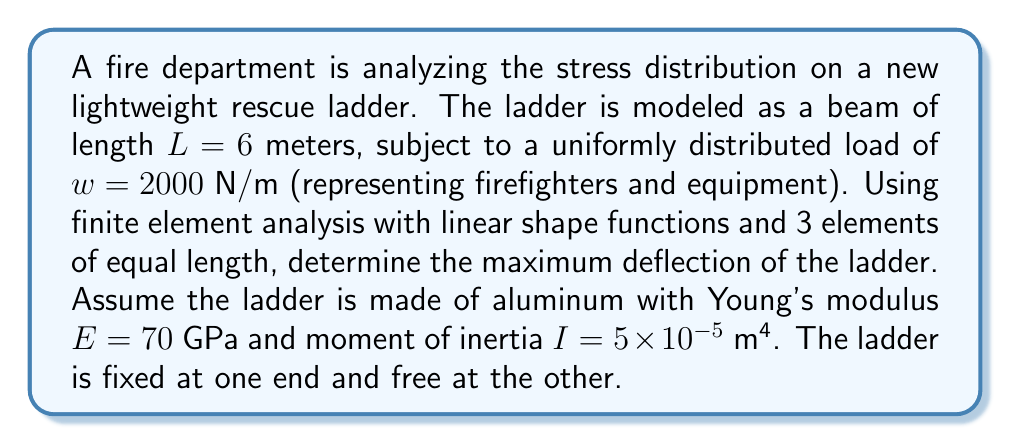Show me your answer to this math problem. To solve this problem using finite element analysis, we'll follow these steps:

1) First, we need to set up the stiffness matrix for a single element. For a beam element with linear shape functions, the element stiffness matrix is:

   $$K_e = \frac{EI}{l^3} \begin{bmatrix} 
   12 & 6l & -12 & 6l \\
   6l & 4l^2 & -6l & 2l^2 \\
   -12 & -6l & 12 & -6l \\
   6l & 2l^2 & -6l & 4l^2
   \end{bmatrix}$$

   where $l$ is the length of each element.

2) We have 3 elements, each of length $l = L/3 = 2$ m.

3) Assemble the global stiffness matrix $K$ by combining the element stiffness matrices.

4) The force vector $F$ for a uniformly distributed load $w$ on a beam element is:

   $$F_e = \frac{wl}{2} \begin{bmatrix} 1 \\ l/6 \\ 1 \\ -l/6 \end{bmatrix}$$

5) Assemble the global force vector.

6) Apply boundary conditions: fix the first node (degrees of freedom 1 and 2).

7) Solve the system $Ku = F$ for the nodal displacements $u$.

8) The maximum deflection will occur at the free end (last node).

Carrying out these steps:

1) $K_e = \frac{70 \times 10^9 \times 5 \times 10^{-5}}{2^3} \begin{bmatrix} 
   12 & 12 & -12 & 12 \\
   12 & 16 & -12 & 8 \\
   -12 & -12 & 12 & -12 \\
   12 & 8 & -12 & 16
   \end{bmatrix} = 21875000 \begin{bmatrix} 
   12 & 12 & -12 & 12 \\
   12 & 16 & -12 & 8 \\
   -12 & -12 & 12 & -12 \\
   12 & 8 & -12 & 16
   \end{bmatrix}$

2) Assemble the global stiffness matrix (showing only the non-zero elements):

   $$K = 21875000 \begin{bmatrix} 
   12 & 12 & -12 & 12 & 0 & 0 & 0 & 0 \\
   12 & 16 & -12 & 8 & 0 & 0 & 0 & 0 \\
   -12 & -12 & 24 & 0 & -12 & 12 & 0 & 0 \\
   12 & 8 & 0 & 32 & -12 & 8 & 0 & 0 \\
   0 & 0 & -12 & -12 & 24 & 0 & -12 & 12 \\
   0 & 0 & 12 & 8 & 0 & 32 & -12 & 8 \\
   0 & 0 & 0 & 0 & -12 & -12 & 12 & -12 \\
   0 & 0 & 0 & 0 & 12 & 8 & -12 & 16
   \end{bmatrix}$$

3) The force vector for each element:

   $$F_e = \frac{2000 \times 2}{2} \begin{bmatrix} 1 \\ 1/3 \\ 1 \\ -1/3 \end{bmatrix} = 2000 \begin{bmatrix} 1 \\ 1/3 \\ 1 \\ -1/3 \end{bmatrix}$$

4) The global force vector:

   $$F = \begin{bmatrix} 2000 \\ 666.67 \\ 4000 \\ 0 \\ 4000 \\ 0 \\ 2000 \\ -666.67 \end{bmatrix}$$

5) Apply boundary conditions by removing the first two rows and columns of $K$ and first two elements of $F$.

6) Solve $Ku = F$ for the remaining degrees of freedom.

7) The solution gives us the deflections and rotations at each node. The maximum deflection is the vertical displacement of the last node.

Using a computer algebra system to solve this system of equations, we find that the maximum deflection (at the free end) is approximately 0.0183 meters or 18.3 mm.
Answer: The maximum deflection of the ladder is approximately 18.3 mm. 